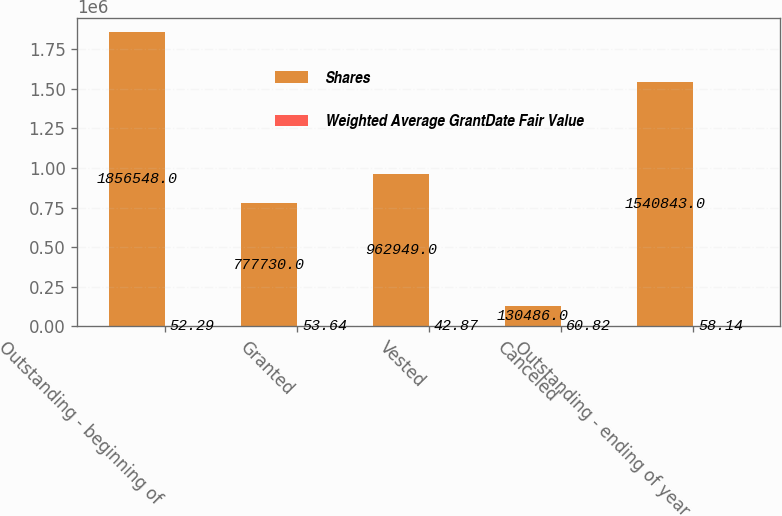<chart> <loc_0><loc_0><loc_500><loc_500><stacked_bar_chart><ecel><fcel>Outstanding - beginning of<fcel>Granted<fcel>Vested<fcel>Canceled<fcel>Outstanding - ending of year<nl><fcel>Shares<fcel>1.85655e+06<fcel>777730<fcel>962949<fcel>130486<fcel>1.54084e+06<nl><fcel>Weighted Average GrantDate Fair Value<fcel>52.29<fcel>53.64<fcel>42.87<fcel>60.82<fcel>58.14<nl></chart> 